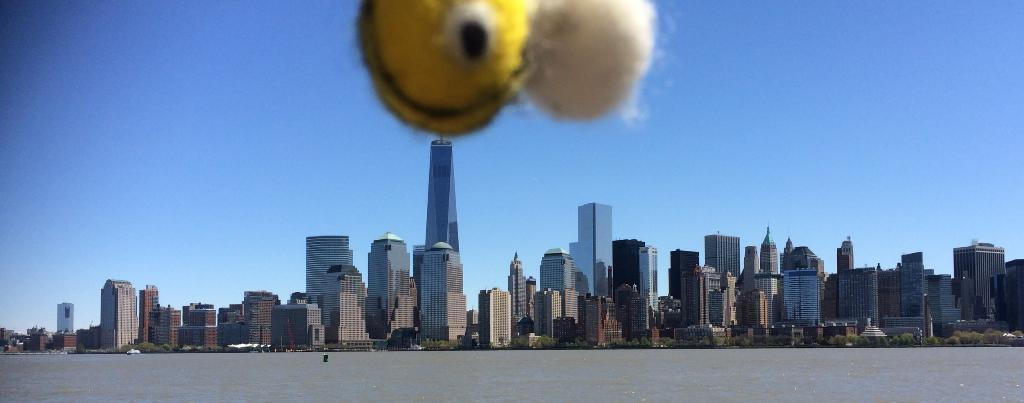What is the primary element visible in the image? There is water in the image. What type of structures can be seen in the image? There are buildings in the image. What other natural elements are present in the image? There are trees in the image. What can be seen in the distance in the image? The sky is visible in the background of the image. What type of lunch is being served to the minister in the image? There is no lunch or minister present in the image. 